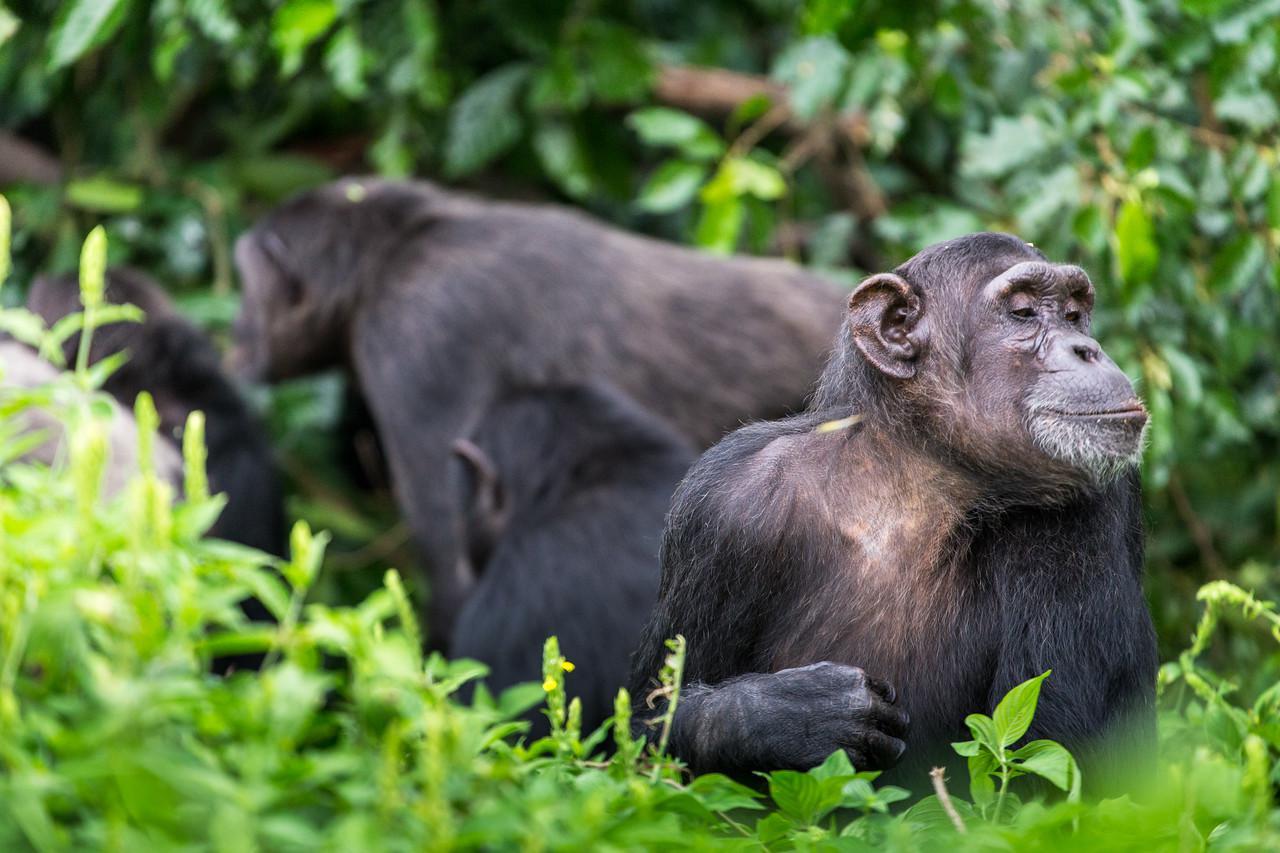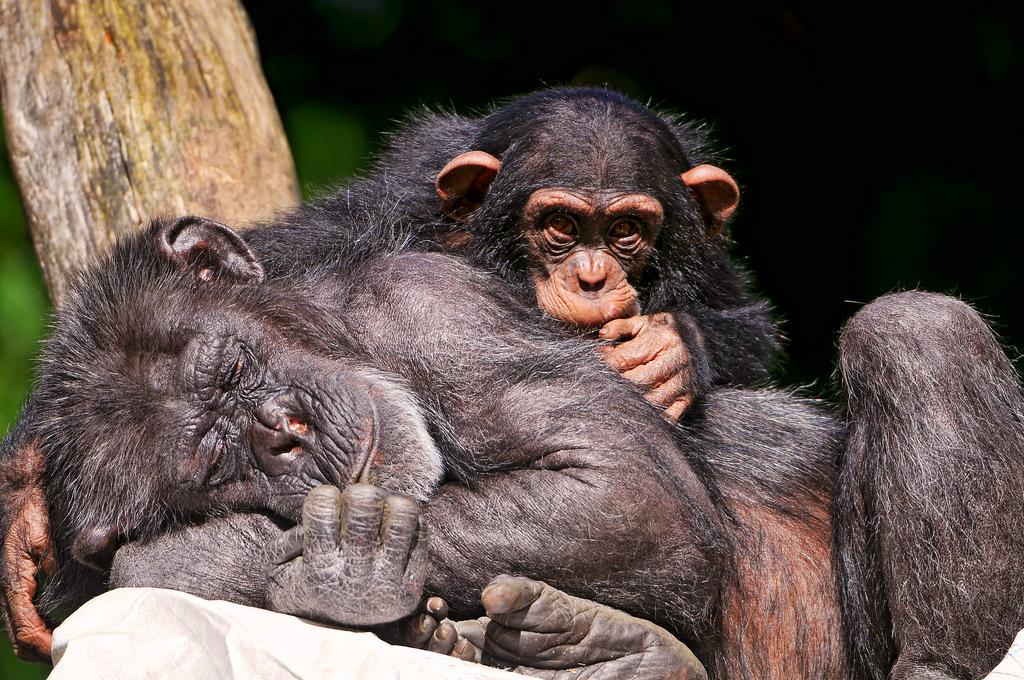The first image is the image on the left, the second image is the image on the right. Assess this claim about the two images: "An image shows an adult chimp in sleeping pose with its head on the left, and a smaller chimp near it.". Correct or not? Answer yes or no. Yes. The first image is the image on the left, the second image is the image on the right. Analyze the images presented: Is the assertion "At least three primates are huddled in the image on the right." valid? Answer yes or no. No. 